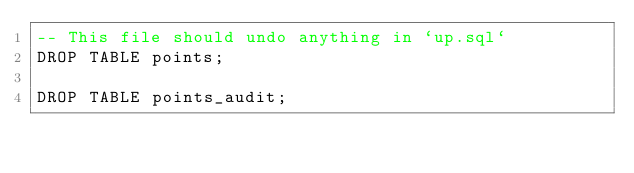Convert code to text. <code><loc_0><loc_0><loc_500><loc_500><_SQL_>-- This file should undo anything in `up.sql`
DROP TABLE points;

DROP TABLE points_audit;</code> 